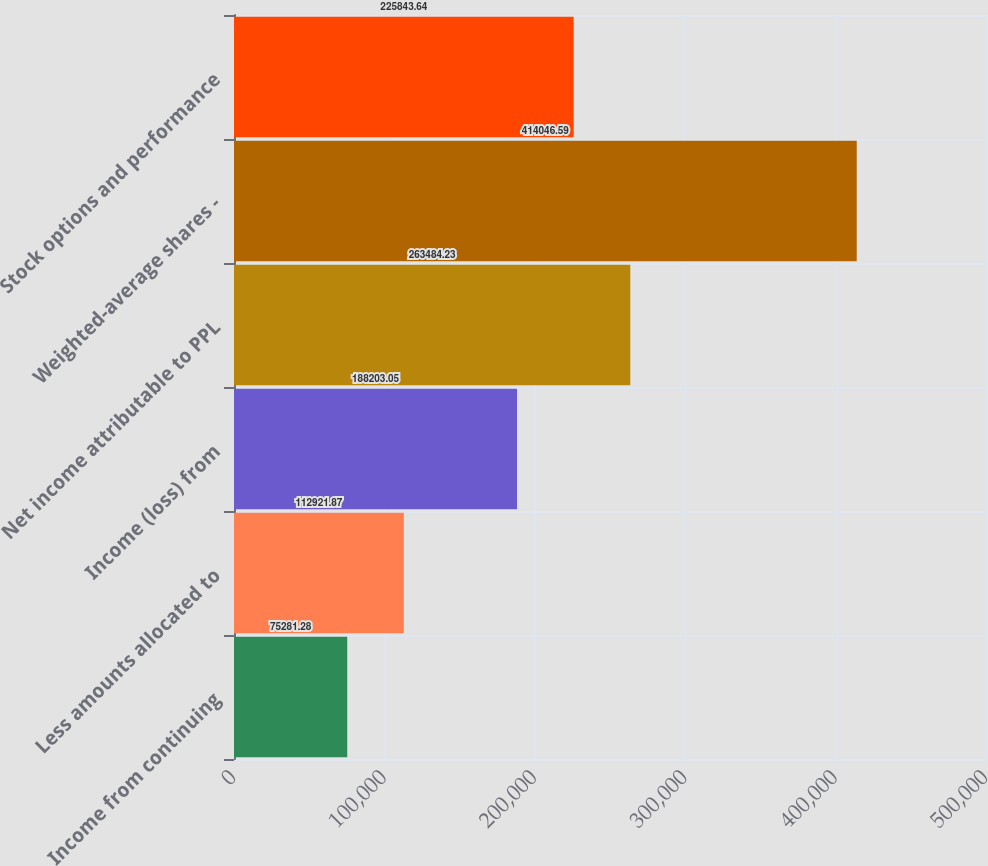Convert chart to OTSL. <chart><loc_0><loc_0><loc_500><loc_500><bar_chart><fcel>Income from continuing<fcel>Less amounts allocated to<fcel>Income (loss) from<fcel>Net income attributable to PPL<fcel>Weighted-average shares -<fcel>Stock options and performance<nl><fcel>75281.3<fcel>112922<fcel>188203<fcel>263484<fcel>414047<fcel>225844<nl></chart> 